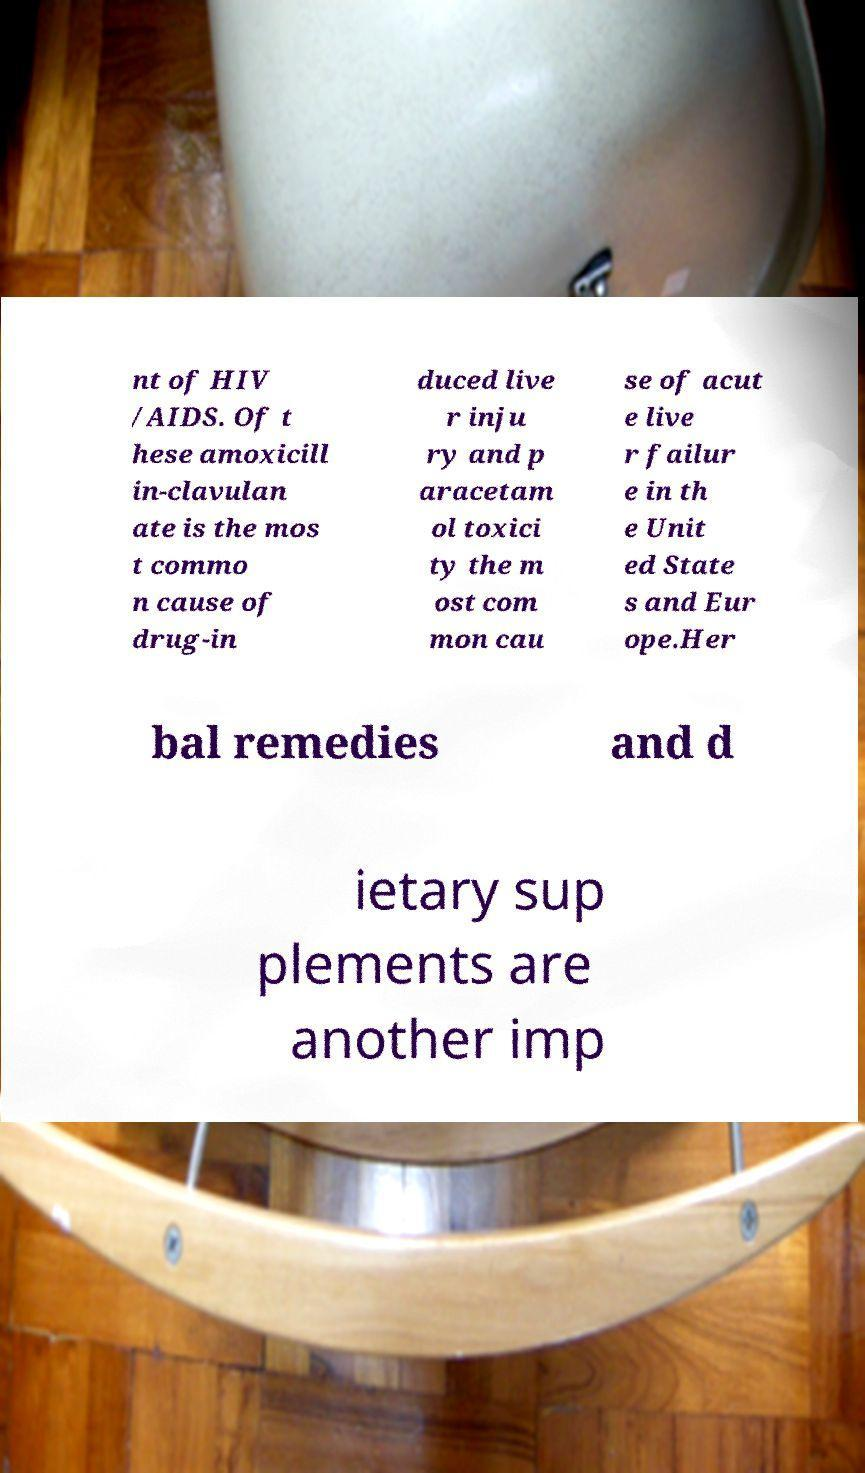Could you extract and type out the text from this image? nt of HIV /AIDS. Of t hese amoxicill in-clavulan ate is the mos t commo n cause of drug-in duced live r inju ry and p aracetam ol toxici ty the m ost com mon cau se of acut e live r failur e in th e Unit ed State s and Eur ope.Her bal remedies and d ietary sup plements are another imp 